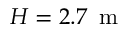<formula> <loc_0><loc_0><loc_500><loc_500>H = 2 . 7 \, m</formula> 